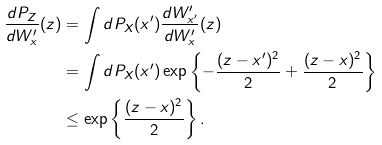<formula> <loc_0><loc_0><loc_500><loc_500>\frac { d P _ { Z } } { d W ^ { \prime } _ { x } } ( z ) & = \int d P _ { X } ( x ^ { \prime } ) \frac { d W ^ { \prime } _ { x ^ { \prime } } } { d W ^ { \prime } _ { x } } ( z ) \\ & = \int d P _ { X } ( x ^ { \prime } ) \exp \left \{ - \frac { ( z - x ^ { \prime } ) ^ { 2 } } { 2 } + \frac { ( z - x ) ^ { 2 } } { 2 } \right \} \\ & \leq \exp \left \{ \frac { ( z - x ) ^ { 2 } } { 2 } \right \} .</formula> 